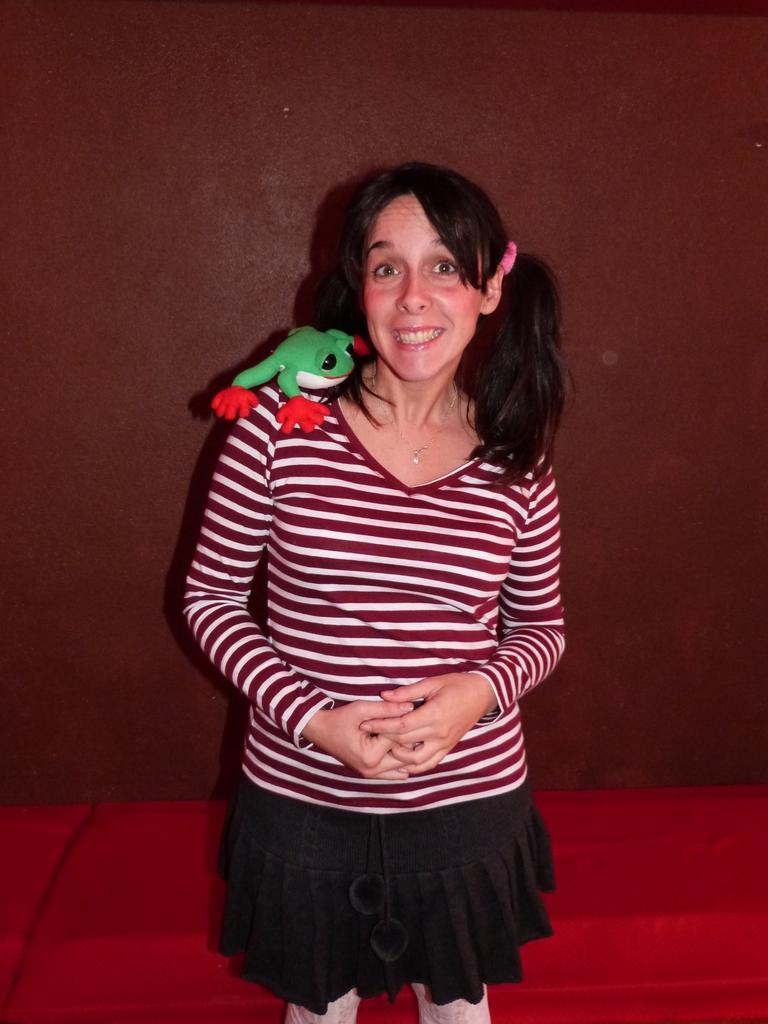How would you summarize this image in a sentence or two? There is one woman standing in the middle of this image and there is one frog toy is present on her shoulders. There is a wall in the background. 